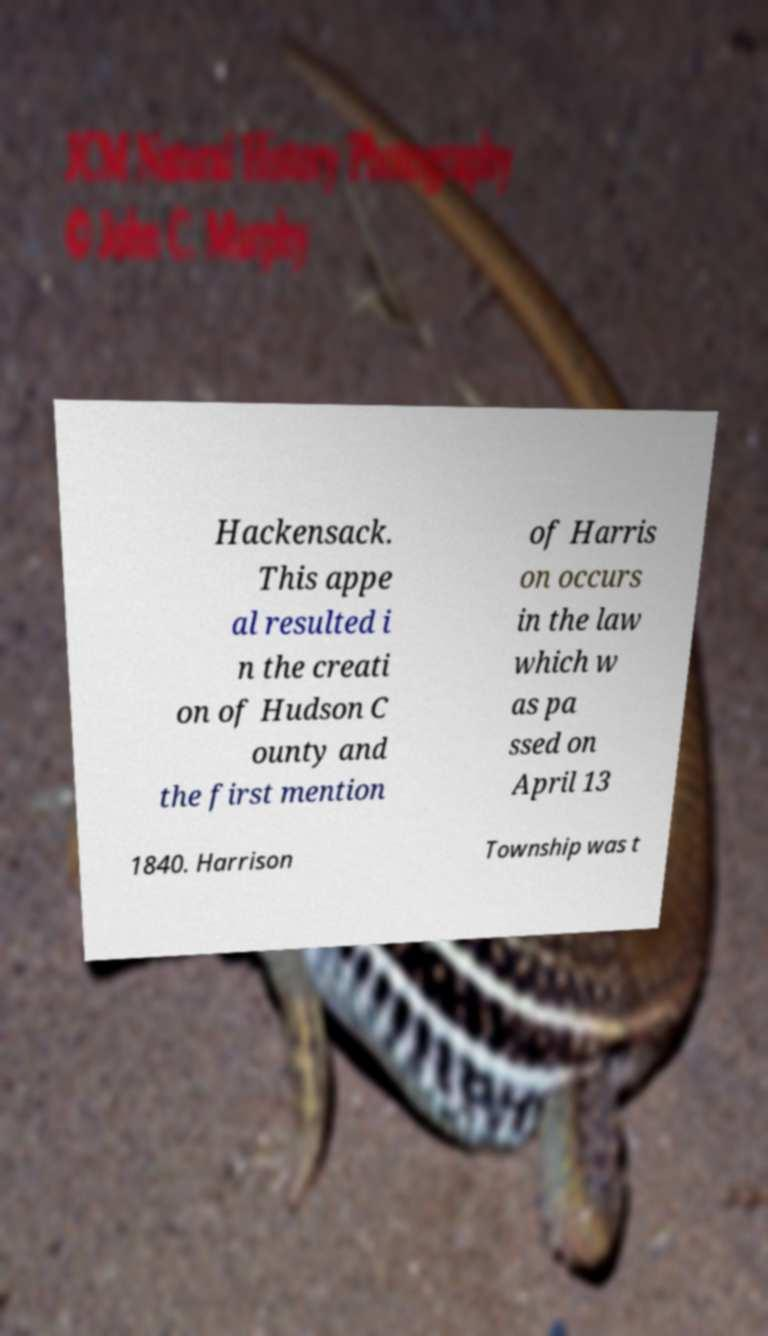Please identify and transcribe the text found in this image. Hackensack. This appe al resulted i n the creati on of Hudson C ounty and the first mention of Harris on occurs in the law which w as pa ssed on April 13 1840. Harrison Township was t 